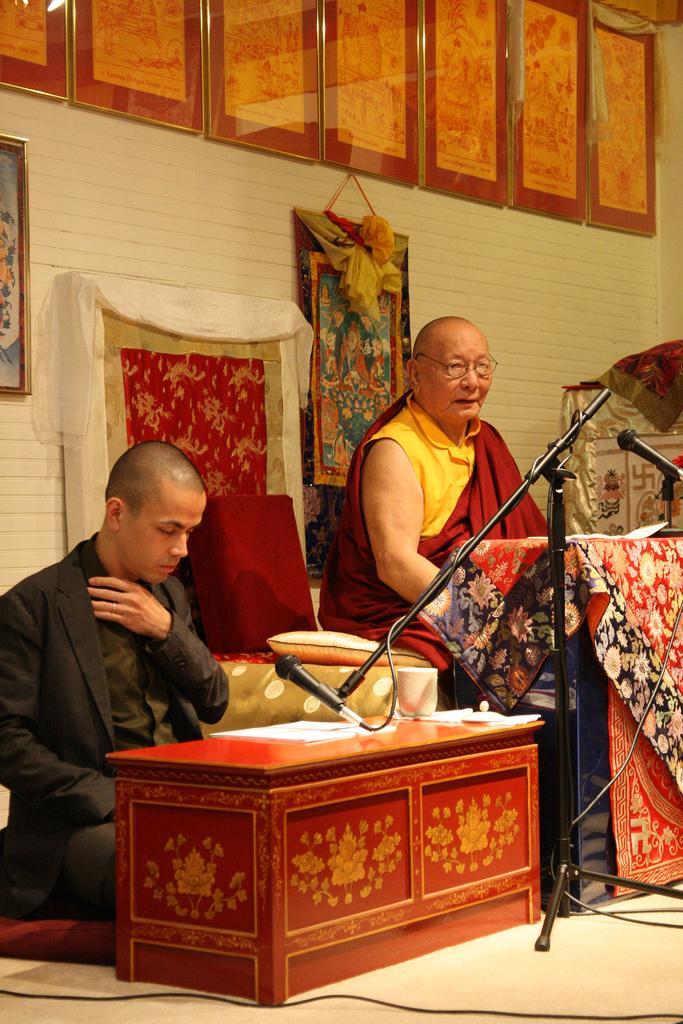How would you summarize this image in a sentence or two? In this image in front there are two persons sitting in front of the table. On top of the table there are papers, mug and a mike. In front of them there is another mike. On the backside there is a wall with the photo frames on it. At the bottom there is a floor. 